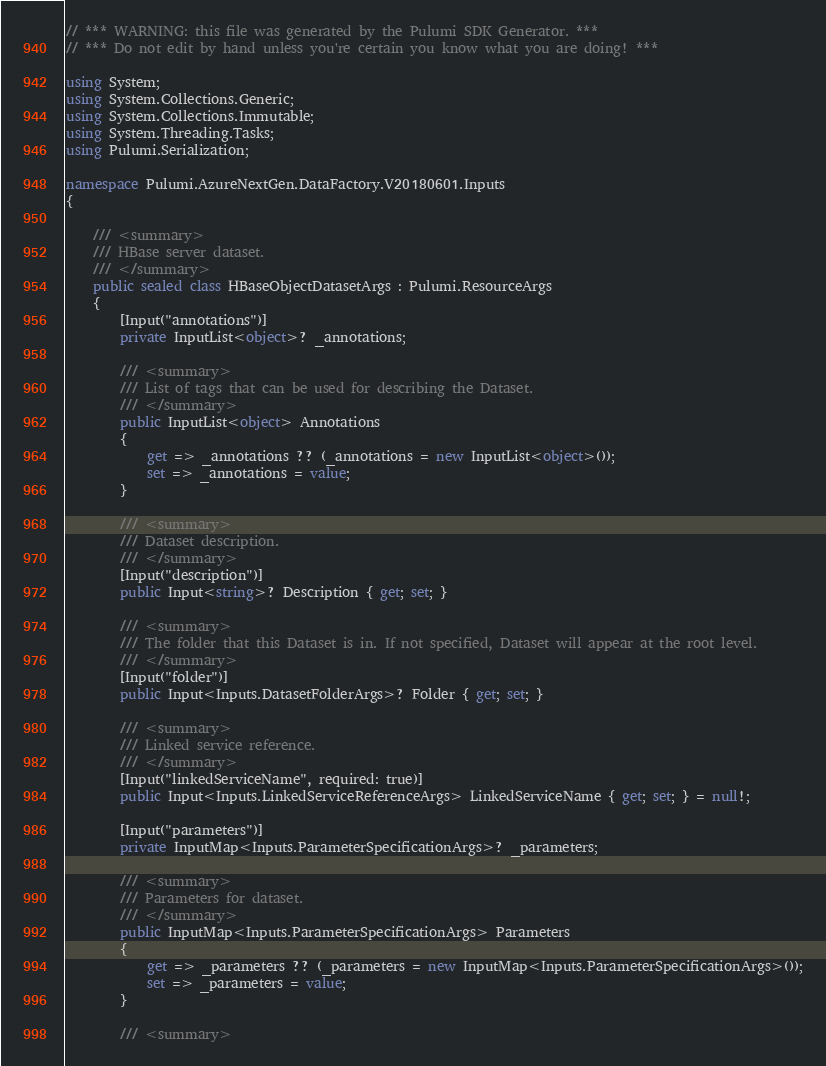Convert code to text. <code><loc_0><loc_0><loc_500><loc_500><_C#_>// *** WARNING: this file was generated by the Pulumi SDK Generator. ***
// *** Do not edit by hand unless you're certain you know what you are doing! ***

using System;
using System.Collections.Generic;
using System.Collections.Immutable;
using System.Threading.Tasks;
using Pulumi.Serialization;

namespace Pulumi.AzureNextGen.DataFactory.V20180601.Inputs
{

    /// <summary>
    /// HBase server dataset.
    /// </summary>
    public sealed class HBaseObjectDatasetArgs : Pulumi.ResourceArgs
    {
        [Input("annotations")]
        private InputList<object>? _annotations;

        /// <summary>
        /// List of tags that can be used for describing the Dataset.
        /// </summary>
        public InputList<object> Annotations
        {
            get => _annotations ?? (_annotations = new InputList<object>());
            set => _annotations = value;
        }

        /// <summary>
        /// Dataset description.
        /// </summary>
        [Input("description")]
        public Input<string>? Description { get; set; }

        /// <summary>
        /// The folder that this Dataset is in. If not specified, Dataset will appear at the root level.
        /// </summary>
        [Input("folder")]
        public Input<Inputs.DatasetFolderArgs>? Folder { get; set; }

        /// <summary>
        /// Linked service reference.
        /// </summary>
        [Input("linkedServiceName", required: true)]
        public Input<Inputs.LinkedServiceReferenceArgs> LinkedServiceName { get; set; } = null!;

        [Input("parameters")]
        private InputMap<Inputs.ParameterSpecificationArgs>? _parameters;

        /// <summary>
        /// Parameters for dataset.
        /// </summary>
        public InputMap<Inputs.ParameterSpecificationArgs> Parameters
        {
            get => _parameters ?? (_parameters = new InputMap<Inputs.ParameterSpecificationArgs>());
            set => _parameters = value;
        }

        /// <summary></code> 